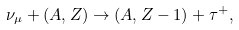Convert formula to latex. <formula><loc_0><loc_0><loc_500><loc_500>\nu _ { \mu } + ( A , Z ) \to ( A , Z - 1 ) + \tau ^ { + } ,</formula> 